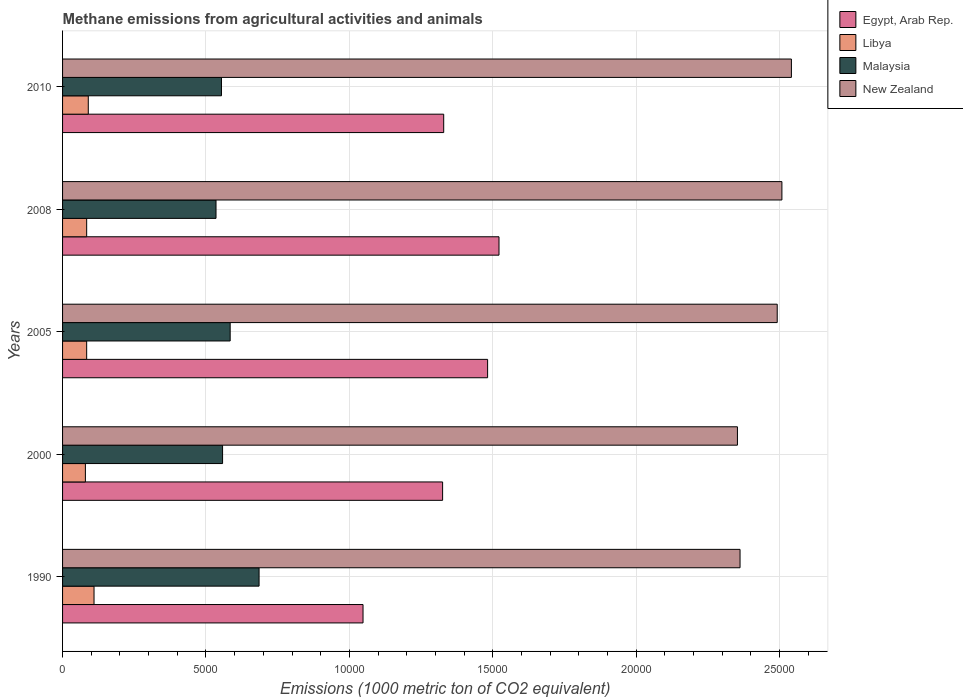How many different coloured bars are there?
Provide a succinct answer. 4. How many groups of bars are there?
Provide a succinct answer. 5. Are the number of bars on each tick of the Y-axis equal?
Make the answer very short. Yes. What is the label of the 4th group of bars from the top?
Make the answer very short. 2000. What is the amount of methane emitted in Egypt, Arab Rep. in 2005?
Offer a very short reply. 1.48e+04. Across all years, what is the maximum amount of methane emitted in Libya?
Offer a terse response. 1097.1. Across all years, what is the minimum amount of methane emitted in Libya?
Offer a terse response. 795.8. In which year was the amount of methane emitted in Malaysia minimum?
Your answer should be compact. 2008. What is the total amount of methane emitted in New Zealand in the graph?
Your response must be concise. 1.23e+05. What is the difference between the amount of methane emitted in New Zealand in 1990 and that in 2008?
Give a very brief answer. -1459.6. What is the difference between the amount of methane emitted in Egypt, Arab Rep. in 1990 and the amount of methane emitted in Libya in 2005?
Your response must be concise. 9635.4. What is the average amount of methane emitted in New Zealand per year?
Offer a very short reply. 2.45e+04. In the year 2005, what is the difference between the amount of methane emitted in Malaysia and amount of methane emitted in New Zealand?
Provide a short and direct response. -1.91e+04. What is the ratio of the amount of methane emitted in Malaysia in 2005 to that in 2010?
Offer a very short reply. 1.05. What is the difference between the highest and the second highest amount of methane emitted in Libya?
Your answer should be very brief. 200.3. What is the difference between the highest and the lowest amount of methane emitted in Malaysia?
Ensure brevity in your answer.  1501.2. In how many years, is the amount of methane emitted in Egypt, Arab Rep. greater than the average amount of methane emitted in Egypt, Arab Rep. taken over all years?
Your response must be concise. 2. Is it the case that in every year, the sum of the amount of methane emitted in Malaysia and amount of methane emitted in New Zealand is greater than the sum of amount of methane emitted in Libya and amount of methane emitted in Egypt, Arab Rep.?
Your answer should be compact. No. What does the 1st bar from the top in 2010 represents?
Your answer should be compact. New Zealand. What does the 3rd bar from the bottom in 2008 represents?
Ensure brevity in your answer.  Malaysia. Are the values on the major ticks of X-axis written in scientific E-notation?
Give a very brief answer. No. What is the title of the graph?
Provide a short and direct response. Methane emissions from agricultural activities and animals. What is the label or title of the X-axis?
Keep it short and to the point. Emissions (1000 metric ton of CO2 equivalent). What is the Emissions (1000 metric ton of CO2 equivalent) in Egypt, Arab Rep. in 1990?
Provide a short and direct response. 1.05e+04. What is the Emissions (1000 metric ton of CO2 equivalent) in Libya in 1990?
Provide a succinct answer. 1097.1. What is the Emissions (1000 metric ton of CO2 equivalent) of Malaysia in 1990?
Your answer should be compact. 6851.5. What is the Emissions (1000 metric ton of CO2 equivalent) of New Zealand in 1990?
Offer a very short reply. 2.36e+04. What is the Emissions (1000 metric ton of CO2 equivalent) of Egypt, Arab Rep. in 2000?
Ensure brevity in your answer.  1.33e+04. What is the Emissions (1000 metric ton of CO2 equivalent) in Libya in 2000?
Your response must be concise. 795.8. What is the Emissions (1000 metric ton of CO2 equivalent) of Malaysia in 2000?
Provide a short and direct response. 5579.2. What is the Emissions (1000 metric ton of CO2 equivalent) in New Zealand in 2000?
Make the answer very short. 2.35e+04. What is the Emissions (1000 metric ton of CO2 equivalent) of Egypt, Arab Rep. in 2005?
Provide a short and direct response. 1.48e+04. What is the Emissions (1000 metric ton of CO2 equivalent) of Libya in 2005?
Your answer should be very brief. 840.7. What is the Emissions (1000 metric ton of CO2 equivalent) in Malaysia in 2005?
Ensure brevity in your answer.  5844. What is the Emissions (1000 metric ton of CO2 equivalent) of New Zealand in 2005?
Ensure brevity in your answer.  2.49e+04. What is the Emissions (1000 metric ton of CO2 equivalent) of Egypt, Arab Rep. in 2008?
Give a very brief answer. 1.52e+04. What is the Emissions (1000 metric ton of CO2 equivalent) in Libya in 2008?
Ensure brevity in your answer.  840.7. What is the Emissions (1000 metric ton of CO2 equivalent) in Malaysia in 2008?
Provide a short and direct response. 5350.3. What is the Emissions (1000 metric ton of CO2 equivalent) in New Zealand in 2008?
Provide a succinct answer. 2.51e+04. What is the Emissions (1000 metric ton of CO2 equivalent) of Egypt, Arab Rep. in 2010?
Your answer should be very brief. 1.33e+04. What is the Emissions (1000 metric ton of CO2 equivalent) in Libya in 2010?
Make the answer very short. 896.8. What is the Emissions (1000 metric ton of CO2 equivalent) in Malaysia in 2010?
Your answer should be compact. 5540.3. What is the Emissions (1000 metric ton of CO2 equivalent) in New Zealand in 2010?
Keep it short and to the point. 2.54e+04. Across all years, what is the maximum Emissions (1000 metric ton of CO2 equivalent) in Egypt, Arab Rep.?
Ensure brevity in your answer.  1.52e+04. Across all years, what is the maximum Emissions (1000 metric ton of CO2 equivalent) of Libya?
Ensure brevity in your answer.  1097.1. Across all years, what is the maximum Emissions (1000 metric ton of CO2 equivalent) in Malaysia?
Keep it short and to the point. 6851.5. Across all years, what is the maximum Emissions (1000 metric ton of CO2 equivalent) of New Zealand?
Offer a very short reply. 2.54e+04. Across all years, what is the minimum Emissions (1000 metric ton of CO2 equivalent) of Egypt, Arab Rep.?
Make the answer very short. 1.05e+04. Across all years, what is the minimum Emissions (1000 metric ton of CO2 equivalent) in Libya?
Your answer should be very brief. 795.8. Across all years, what is the minimum Emissions (1000 metric ton of CO2 equivalent) in Malaysia?
Your answer should be compact. 5350.3. Across all years, what is the minimum Emissions (1000 metric ton of CO2 equivalent) in New Zealand?
Give a very brief answer. 2.35e+04. What is the total Emissions (1000 metric ton of CO2 equivalent) in Egypt, Arab Rep. in the graph?
Your response must be concise. 6.71e+04. What is the total Emissions (1000 metric ton of CO2 equivalent) in Libya in the graph?
Your response must be concise. 4471.1. What is the total Emissions (1000 metric ton of CO2 equivalent) of Malaysia in the graph?
Your response must be concise. 2.92e+04. What is the total Emissions (1000 metric ton of CO2 equivalent) in New Zealand in the graph?
Make the answer very short. 1.23e+05. What is the difference between the Emissions (1000 metric ton of CO2 equivalent) in Egypt, Arab Rep. in 1990 and that in 2000?
Keep it short and to the point. -2774.9. What is the difference between the Emissions (1000 metric ton of CO2 equivalent) in Libya in 1990 and that in 2000?
Provide a succinct answer. 301.3. What is the difference between the Emissions (1000 metric ton of CO2 equivalent) in Malaysia in 1990 and that in 2000?
Give a very brief answer. 1272.3. What is the difference between the Emissions (1000 metric ton of CO2 equivalent) in New Zealand in 1990 and that in 2000?
Provide a short and direct response. 90.9. What is the difference between the Emissions (1000 metric ton of CO2 equivalent) in Egypt, Arab Rep. in 1990 and that in 2005?
Ensure brevity in your answer.  -4343.8. What is the difference between the Emissions (1000 metric ton of CO2 equivalent) in Libya in 1990 and that in 2005?
Offer a very short reply. 256.4. What is the difference between the Emissions (1000 metric ton of CO2 equivalent) of Malaysia in 1990 and that in 2005?
Offer a very short reply. 1007.5. What is the difference between the Emissions (1000 metric ton of CO2 equivalent) in New Zealand in 1990 and that in 2005?
Provide a succinct answer. -1296. What is the difference between the Emissions (1000 metric ton of CO2 equivalent) in Egypt, Arab Rep. in 1990 and that in 2008?
Offer a terse response. -4741.1. What is the difference between the Emissions (1000 metric ton of CO2 equivalent) in Libya in 1990 and that in 2008?
Ensure brevity in your answer.  256.4. What is the difference between the Emissions (1000 metric ton of CO2 equivalent) of Malaysia in 1990 and that in 2008?
Give a very brief answer. 1501.2. What is the difference between the Emissions (1000 metric ton of CO2 equivalent) of New Zealand in 1990 and that in 2008?
Ensure brevity in your answer.  -1459.6. What is the difference between the Emissions (1000 metric ton of CO2 equivalent) in Egypt, Arab Rep. in 1990 and that in 2010?
Keep it short and to the point. -2813. What is the difference between the Emissions (1000 metric ton of CO2 equivalent) of Libya in 1990 and that in 2010?
Provide a succinct answer. 200.3. What is the difference between the Emissions (1000 metric ton of CO2 equivalent) of Malaysia in 1990 and that in 2010?
Provide a succinct answer. 1311.2. What is the difference between the Emissions (1000 metric ton of CO2 equivalent) of New Zealand in 1990 and that in 2010?
Offer a terse response. -1790.8. What is the difference between the Emissions (1000 metric ton of CO2 equivalent) of Egypt, Arab Rep. in 2000 and that in 2005?
Offer a terse response. -1568.9. What is the difference between the Emissions (1000 metric ton of CO2 equivalent) in Libya in 2000 and that in 2005?
Your response must be concise. -44.9. What is the difference between the Emissions (1000 metric ton of CO2 equivalent) in Malaysia in 2000 and that in 2005?
Offer a terse response. -264.8. What is the difference between the Emissions (1000 metric ton of CO2 equivalent) in New Zealand in 2000 and that in 2005?
Your answer should be very brief. -1386.9. What is the difference between the Emissions (1000 metric ton of CO2 equivalent) of Egypt, Arab Rep. in 2000 and that in 2008?
Your answer should be very brief. -1966.2. What is the difference between the Emissions (1000 metric ton of CO2 equivalent) in Libya in 2000 and that in 2008?
Your response must be concise. -44.9. What is the difference between the Emissions (1000 metric ton of CO2 equivalent) in Malaysia in 2000 and that in 2008?
Provide a succinct answer. 228.9. What is the difference between the Emissions (1000 metric ton of CO2 equivalent) in New Zealand in 2000 and that in 2008?
Your response must be concise. -1550.5. What is the difference between the Emissions (1000 metric ton of CO2 equivalent) in Egypt, Arab Rep. in 2000 and that in 2010?
Keep it short and to the point. -38.1. What is the difference between the Emissions (1000 metric ton of CO2 equivalent) of Libya in 2000 and that in 2010?
Offer a terse response. -101. What is the difference between the Emissions (1000 metric ton of CO2 equivalent) in Malaysia in 2000 and that in 2010?
Ensure brevity in your answer.  38.9. What is the difference between the Emissions (1000 metric ton of CO2 equivalent) of New Zealand in 2000 and that in 2010?
Keep it short and to the point. -1881.7. What is the difference between the Emissions (1000 metric ton of CO2 equivalent) of Egypt, Arab Rep. in 2005 and that in 2008?
Your answer should be compact. -397.3. What is the difference between the Emissions (1000 metric ton of CO2 equivalent) in Malaysia in 2005 and that in 2008?
Offer a very short reply. 493.7. What is the difference between the Emissions (1000 metric ton of CO2 equivalent) in New Zealand in 2005 and that in 2008?
Make the answer very short. -163.6. What is the difference between the Emissions (1000 metric ton of CO2 equivalent) of Egypt, Arab Rep. in 2005 and that in 2010?
Keep it short and to the point. 1530.8. What is the difference between the Emissions (1000 metric ton of CO2 equivalent) of Libya in 2005 and that in 2010?
Your response must be concise. -56.1. What is the difference between the Emissions (1000 metric ton of CO2 equivalent) in Malaysia in 2005 and that in 2010?
Provide a short and direct response. 303.7. What is the difference between the Emissions (1000 metric ton of CO2 equivalent) in New Zealand in 2005 and that in 2010?
Give a very brief answer. -494.8. What is the difference between the Emissions (1000 metric ton of CO2 equivalent) of Egypt, Arab Rep. in 2008 and that in 2010?
Your answer should be very brief. 1928.1. What is the difference between the Emissions (1000 metric ton of CO2 equivalent) of Libya in 2008 and that in 2010?
Your answer should be compact. -56.1. What is the difference between the Emissions (1000 metric ton of CO2 equivalent) in Malaysia in 2008 and that in 2010?
Offer a very short reply. -190. What is the difference between the Emissions (1000 metric ton of CO2 equivalent) in New Zealand in 2008 and that in 2010?
Make the answer very short. -331.2. What is the difference between the Emissions (1000 metric ton of CO2 equivalent) in Egypt, Arab Rep. in 1990 and the Emissions (1000 metric ton of CO2 equivalent) in Libya in 2000?
Your response must be concise. 9680.3. What is the difference between the Emissions (1000 metric ton of CO2 equivalent) in Egypt, Arab Rep. in 1990 and the Emissions (1000 metric ton of CO2 equivalent) in Malaysia in 2000?
Your answer should be compact. 4896.9. What is the difference between the Emissions (1000 metric ton of CO2 equivalent) in Egypt, Arab Rep. in 1990 and the Emissions (1000 metric ton of CO2 equivalent) in New Zealand in 2000?
Offer a terse response. -1.31e+04. What is the difference between the Emissions (1000 metric ton of CO2 equivalent) of Libya in 1990 and the Emissions (1000 metric ton of CO2 equivalent) of Malaysia in 2000?
Provide a succinct answer. -4482.1. What is the difference between the Emissions (1000 metric ton of CO2 equivalent) in Libya in 1990 and the Emissions (1000 metric ton of CO2 equivalent) in New Zealand in 2000?
Your answer should be compact. -2.24e+04. What is the difference between the Emissions (1000 metric ton of CO2 equivalent) in Malaysia in 1990 and the Emissions (1000 metric ton of CO2 equivalent) in New Zealand in 2000?
Ensure brevity in your answer.  -1.67e+04. What is the difference between the Emissions (1000 metric ton of CO2 equivalent) of Egypt, Arab Rep. in 1990 and the Emissions (1000 metric ton of CO2 equivalent) of Libya in 2005?
Provide a short and direct response. 9635.4. What is the difference between the Emissions (1000 metric ton of CO2 equivalent) of Egypt, Arab Rep. in 1990 and the Emissions (1000 metric ton of CO2 equivalent) of Malaysia in 2005?
Ensure brevity in your answer.  4632.1. What is the difference between the Emissions (1000 metric ton of CO2 equivalent) in Egypt, Arab Rep. in 1990 and the Emissions (1000 metric ton of CO2 equivalent) in New Zealand in 2005?
Offer a terse response. -1.44e+04. What is the difference between the Emissions (1000 metric ton of CO2 equivalent) in Libya in 1990 and the Emissions (1000 metric ton of CO2 equivalent) in Malaysia in 2005?
Provide a short and direct response. -4746.9. What is the difference between the Emissions (1000 metric ton of CO2 equivalent) in Libya in 1990 and the Emissions (1000 metric ton of CO2 equivalent) in New Zealand in 2005?
Keep it short and to the point. -2.38e+04. What is the difference between the Emissions (1000 metric ton of CO2 equivalent) of Malaysia in 1990 and the Emissions (1000 metric ton of CO2 equivalent) of New Zealand in 2005?
Ensure brevity in your answer.  -1.81e+04. What is the difference between the Emissions (1000 metric ton of CO2 equivalent) of Egypt, Arab Rep. in 1990 and the Emissions (1000 metric ton of CO2 equivalent) of Libya in 2008?
Your answer should be very brief. 9635.4. What is the difference between the Emissions (1000 metric ton of CO2 equivalent) in Egypt, Arab Rep. in 1990 and the Emissions (1000 metric ton of CO2 equivalent) in Malaysia in 2008?
Your response must be concise. 5125.8. What is the difference between the Emissions (1000 metric ton of CO2 equivalent) in Egypt, Arab Rep. in 1990 and the Emissions (1000 metric ton of CO2 equivalent) in New Zealand in 2008?
Make the answer very short. -1.46e+04. What is the difference between the Emissions (1000 metric ton of CO2 equivalent) of Libya in 1990 and the Emissions (1000 metric ton of CO2 equivalent) of Malaysia in 2008?
Your answer should be compact. -4253.2. What is the difference between the Emissions (1000 metric ton of CO2 equivalent) in Libya in 1990 and the Emissions (1000 metric ton of CO2 equivalent) in New Zealand in 2008?
Make the answer very short. -2.40e+04. What is the difference between the Emissions (1000 metric ton of CO2 equivalent) in Malaysia in 1990 and the Emissions (1000 metric ton of CO2 equivalent) in New Zealand in 2008?
Make the answer very short. -1.82e+04. What is the difference between the Emissions (1000 metric ton of CO2 equivalent) in Egypt, Arab Rep. in 1990 and the Emissions (1000 metric ton of CO2 equivalent) in Libya in 2010?
Give a very brief answer. 9579.3. What is the difference between the Emissions (1000 metric ton of CO2 equivalent) in Egypt, Arab Rep. in 1990 and the Emissions (1000 metric ton of CO2 equivalent) in Malaysia in 2010?
Keep it short and to the point. 4935.8. What is the difference between the Emissions (1000 metric ton of CO2 equivalent) of Egypt, Arab Rep. in 1990 and the Emissions (1000 metric ton of CO2 equivalent) of New Zealand in 2010?
Give a very brief answer. -1.49e+04. What is the difference between the Emissions (1000 metric ton of CO2 equivalent) of Libya in 1990 and the Emissions (1000 metric ton of CO2 equivalent) of Malaysia in 2010?
Offer a terse response. -4443.2. What is the difference between the Emissions (1000 metric ton of CO2 equivalent) in Libya in 1990 and the Emissions (1000 metric ton of CO2 equivalent) in New Zealand in 2010?
Your response must be concise. -2.43e+04. What is the difference between the Emissions (1000 metric ton of CO2 equivalent) in Malaysia in 1990 and the Emissions (1000 metric ton of CO2 equivalent) in New Zealand in 2010?
Provide a succinct answer. -1.86e+04. What is the difference between the Emissions (1000 metric ton of CO2 equivalent) of Egypt, Arab Rep. in 2000 and the Emissions (1000 metric ton of CO2 equivalent) of Libya in 2005?
Your answer should be compact. 1.24e+04. What is the difference between the Emissions (1000 metric ton of CO2 equivalent) of Egypt, Arab Rep. in 2000 and the Emissions (1000 metric ton of CO2 equivalent) of Malaysia in 2005?
Your answer should be compact. 7407. What is the difference between the Emissions (1000 metric ton of CO2 equivalent) of Egypt, Arab Rep. in 2000 and the Emissions (1000 metric ton of CO2 equivalent) of New Zealand in 2005?
Give a very brief answer. -1.17e+04. What is the difference between the Emissions (1000 metric ton of CO2 equivalent) of Libya in 2000 and the Emissions (1000 metric ton of CO2 equivalent) of Malaysia in 2005?
Provide a short and direct response. -5048.2. What is the difference between the Emissions (1000 metric ton of CO2 equivalent) in Libya in 2000 and the Emissions (1000 metric ton of CO2 equivalent) in New Zealand in 2005?
Offer a very short reply. -2.41e+04. What is the difference between the Emissions (1000 metric ton of CO2 equivalent) of Malaysia in 2000 and the Emissions (1000 metric ton of CO2 equivalent) of New Zealand in 2005?
Your answer should be compact. -1.93e+04. What is the difference between the Emissions (1000 metric ton of CO2 equivalent) in Egypt, Arab Rep. in 2000 and the Emissions (1000 metric ton of CO2 equivalent) in Libya in 2008?
Provide a short and direct response. 1.24e+04. What is the difference between the Emissions (1000 metric ton of CO2 equivalent) of Egypt, Arab Rep. in 2000 and the Emissions (1000 metric ton of CO2 equivalent) of Malaysia in 2008?
Keep it short and to the point. 7900.7. What is the difference between the Emissions (1000 metric ton of CO2 equivalent) of Egypt, Arab Rep. in 2000 and the Emissions (1000 metric ton of CO2 equivalent) of New Zealand in 2008?
Give a very brief answer. -1.18e+04. What is the difference between the Emissions (1000 metric ton of CO2 equivalent) of Libya in 2000 and the Emissions (1000 metric ton of CO2 equivalent) of Malaysia in 2008?
Your response must be concise. -4554.5. What is the difference between the Emissions (1000 metric ton of CO2 equivalent) in Libya in 2000 and the Emissions (1000 metric ton of CO2 equivalent) in New Zealand in 2008?
Keep it short and to the point. -2.43e+04. What is the difference between the Emissions (1000 metric ton of CO2 equivalent) in Malaysia in 2000 and the Emissions (1000 metric ton of CO2 equivalent) in New Zealand in 2008?
Your response must be concise. -1.95e+04. What is the difference between the Emissions (1000 metric ton of CO2 equivalent) in Egypt, Arab Rep. in 2000 and the Emissions (1000 metric ton of CO2 equivalent) in Libya in 2010?
Offer a very short reply. 1.24e+04. What is the difference between the Emissions (1000 metric ton of CO2 equivalent) of Egypt, Arab Rep. in 2000 and the Emissions (1000 metric ton of CO2 equivalent) of Malaysia in 2010?
Your answer should be very brief. 7710.7. What is the difference between the Emissions (1000 metric ton of CO2 equivalent) of Egypt, Arab Rep. in 2000 and the Emissions (1000 metric ton of CO2 equivalent) of New Zealand in 2010?
Your answer should be very brief. -1.22e+04. What is the difference between the Emissions (1000 metric ton of CO2 equivalent) of Libya in 2000 and the Emissions (1000 metric ton of CO2 equivalent) of Malaysia in 2010?
Give a very brief answer. -4744.5. What is the difference between the Emissions (1000 metric ton of CO2 equivalent) of Libya in 2000 and the Emissions (1000 metric ton of CO2 equivalent) of New Zealand in 2010?
Offer a very short reply. -2.46e+04. What is the difference between the Emissions (1000 metric ton of CO2 equivalent) of Malaysia in 2000 and the Emissions (1000 metric ton of CO2 equivalent) of New Zealand in 2010?
Your response must be concise. -1.98e+04. What is the difference between the Emissions (1000 metric ton of CO2 equivalent) of Egypt, Arab Rep. in 2005 and the Emissions (1000 metric ton of CO2 equivalent) of Libya in 2008?
Your answer should be very brief. 1.40e+04. What is the difference between the Emissions (1000 metric ton of CO2 equivalent) of Egypt, Arab Rep. in 2005 and the Emissions (1000 metric ton of CO2 equivalent) of Malaysia in 2008?
Give a very brief answer. 9469.6. What is the difference between the Emissions (1000 metric ton of CO2 equivalent) in Egypt, Arab Rep. in 2005 and the Emissions (1000 metric ton of CO2 equivalent) in New Zealand in 2008?
Offer a very short reply. -1.03e+04. What is the difference between the Emissions (1000 metric ton of CO2 equivalent) of Libya in 2005 and the Emissions (1000 metric ton of CO2 equivalent) of Malaysia in 2008?
Your answer should be compact. -4509.6. What is the difference between the Emissions (1000 metric ton of CO2 equivalent) in Libya in 2005 and the Emissions (1000 metric ton of CO2 equivalent) in New Zealand in 2008?
Ensure brevity in your answer.  -2.42e+04. What is the difference between the Emissions (1000 metric ton of CO2 equivalent) in Malaysia in 2005 and the Emissions (1000 metric ton of CO2 equivalent) in New Zealand in 2008?
Make the answer very short. -1.92e+04. What is the difference between the Emissions (1000 metric ton of CO2 equivalent) of Egypt, Arab Rep. in 2005 and the Emissions (1000 metric ton of CO2 equivalent) of Libya in 2010?
Your response must be concise. 1.39e+04. What is the difference between the Emissions (1000 metric ton of CO2 equivalent) in Egypt, Arab Rep. in 2005 and the Emissions (1000 metric ton of CO2 equivalent) in Malaysia in 2010?
Make the answer very short. 9279.6. What is the difference between the Emissions (1000 metric ton of CO2 equivalent) in Egypt, Arab Rep. in 2005 and the Emissions (1000 metric ton of CO2 equivalent) in New Zealand in 2010?
Your response must be concise. -1.06e+04. What is the difference between the Emissions (1000 metric ton of CO2 equivalent) of Libya in 2005 and the Emissions (1000 metric ton of CO2 equivalent) of Malaysia in 2010?
Offer a very short reply. -4699.6. What is the difference between the Emissions (1000 metric ton of CO2 equivalent) of Libya in 2005 and the Emissions (1000 metric ton of CO2 equivalent) of New Zealand in 2010?
Your response must be concise. -2.46e+04. What is the difference between the Emissions (1000 metric ton of CO2 equivalent) of Malaysia in 2005 and the Emissions (1000 metric ton of CO2 equivalent) of New Zealand in 2010?
Offer a very short reply. -1.96e+04. What is the difference between the Emissions (1000 metric ton of CO2 equivalent) of Egypt, Arab Rep. in 2008 and the Emissions (1000 metric ton of CO2 equivalent) of Libya in 2010?
Keep it short and to the point. 1.43e+04. What is the difference between the Emissions (1000 metric ton of CO2 equivalent) in Egypt, Arab Rep. in 2008 and the Emissions (1000 metric ton of CO2 equivalent) in Malaysia in 2010?
Offer a very short reply. 9676.9. What is the difference between the Emissions (1000 metric ton of CO2 equivalent) in Egypt, Arab Rep. in 2008 and the Emissions (1000 metric ton of CO2 equivalent) in New Zealand in 2010?
Offer a very short reply. -1.02e+04. What is the difference between the Emissions (1000 metric ton of CO2 equivalent) of Libya in 2008 and the Emissions (1000 metric ton of CO2 equivalent) of Malaysia in 2010?
Offer a very short reply. -4699.6. What is the difference between the Emissions (1000 metric ton of CO2 equivalent) in Libya in 2008 and the Emissions (1000 metric ton of CO2 equivalent) in New Zealand in 2010?
Offer a very short reply. -2.46e+04. What is the difference between the Emissions (1000 metric ton of CO2 equivalent) in Malaysia in 2008 and the Emissions (1000 metric ton of CO2 equivalent) in New Zealand in 2010?
Your answer should be very brief. -2.01e+04. What is the average Emissions (1000 metric ton of CO2 equivalent) in Egypt, Arab Rep. per year?
Provide a short and direct response. 1.34e+04. What is the average Emissions (1000 metric ton of CO2 equivalent) in Libya per year?
Ensure brevity in your answer.  894.22. What is the average Emissions (1000 metric ton of CO2 equivalent) of Malaysia per year?
Make the answer very short. 5833.06. What is the average Emissions (1000 metric ton of CO2 equivalent) of New Zealand per year?
Your response must be concise. 2.45e+04. In the year 1990, what is the difference between the Emissions (1000 metric ton of CO2 equivalent) of Egypt, Arab Rep. and Emissions (1000 metric ton of CO2 equivalent) of Libya?
Provide a succinct answer. 9379. In the year 1990, what is the difference between the Emissions (1000 metric ton of CO2 equivalent) in Egypt, Arab Rep. and Emissions (1000 metric ton of CO2 equivalent) in Malaysia?
Offer a very short reply. 3624.6. In the year 1990, what is the difference between the Emissions (1000 metric ton of CO2 equivalent) in Egypt, Arab Rep. and Emissions (1000 metric ton of CO2 equivalent) in New Zealand?
Your response must be concise. -1.31e+04. In the year 1990, what is the difference between the Emissions (1000 metric ton of CO2 equivalent) of Libya and Emissions (1000 metric ton of CO2 equivalent) of Malaysia?
Your response must be concise. -5754.4. In the year 1990, what is the difference between the Emissions (1000 metric ton of CO2 equivalent) in Libya and Emissions (1000 metric ton of CO2 equivalent) in New Zealand?
Your answer should be compact. -2.25e+04. In the year 1990, what is the difference between the Emissions (1000 metric ton of CO2 equivalent) in Malaysia and Emissions (1000 metric ton of CO2 equivalent) in New Zealand?
Your response must be concise. -1.68e+04. In the year 2000, what is the difference between the Emissions (1000 metric ton of CO2 equivalent) of Egypt, Arab Rep. and Emissions (1000 metric ton of CO2 equivalent) of Libya?
Make the answer very short. 1.25e+04. In the year 2000, what is the difference between the Emissions (1000 metric ton of CO2 equivalent) in Egypt, Arab Rep. and Emissions (1000 metric ton of CO2 equivalent) in Malaysia?
Offer a terse response. 7671.8. In the year 2000, what is the difference between the Emissions (1000 metric ton of CO2 equivalent) in Egypt, Arab Rep. and Emissions (1000 metric ton of CO2 equivalent) in New Zealand?
Offer a terse response. -1.03e+04. In the year 2000, what is the difference between the Emissions (1000 metric ton of CO2 equivalent) of Libya and Emissions (1000 metric ton of CO2 equivalent) of Malaysia?
Make the answer very short. -4783.4. In the year 2000, what is the difference between the Emissions (1000 metric ton of CO2 equivalent) of Libya and Emissions (1000 metric ton of CO2 equivalent) of New Zealand?
Keep it short and to the point. -2.27e+04. In the year 2000, what is the difference between the Emissions (1000 metric ton of CO2 equivalent) in Malaysia and Emissions (1000 metric ton of CO2 equivalent) in New Zealand?
Offer a terse response. -1.80e+04. In the year 2005, what is the difference between the Emissions (1000 metric ton of CO2 equivalent) of Egypt, Arab Rep. and Emissions (1000 metric ton of CO2 equivalent) of Libya?
Ensure brevity in your answer.  1.40e+04. In the year 2005, what is the difference between the Emissions (1000 metric ton of CO2 equivalent) of Egypt, Arab Rep. and Emissions (1000 metric ton of CO2 equivalent) of Malaysia?
Offer a terse response. 8975.9. In the year 2005, what is the difference between the Emissions (1000 metric ton of CO2 equivalent) in Egypt, Arab Rep. and Emissions (1000 metric ton of CO2 equivalent) in New Zealand?
Provide a succinct answer. -1.01e+04. In the year 2005, what is the difference between the Emissions (1000 metric ton of CO2 equivalent) in Libya and Emissions (1000 metric ton of CO2 equivalent) in Malaysia?
Your response must be concise. -5003.3. In the year 2005, what is the difference between the Emissions (1000 metric ton of CO2 equivalent) of Libya and Emissions (1000 metric ton of CO2 equivalent) of New Zealand?
Make the answer very short. -2.41e+04. In the year 2005, what is the difference between the Emissions (1000 metric ton of CO2 equivalent) in Malaysia and Emissions (1000 metric ton of CO2 equivalent) in New Zealand?
Your response must be concise. -1.91e+04. In the year 2008, what is the difference between the Emissions (1000 metric ton of CO2 equivalent) in Egypt, Arab Rep. and Emissions (1000 metric ton of CO2 equivalent) in Libya?
Offer a very short reply. 1.44e+04. In the year 2008, what is the difference between the Emissions (1000 metric ton of CO2 equivalent) in Egypt, Arab Rep. and Emissions (1000 metric ton of CO2 equivalent) in Malaysia?
Give a very brief answer. 9866.9. In the year 2008, what is the difference between the Emissions (1000 metric ton of CO2 equivalent) of Egypt, Arab Rep. and Emissions (1000 metric ton of CO2 equivalent) of New Zealand?
Keep it short and to the point. -9864. In the year 2008, what is the difference between the Emissions (1000 metric ton of CO2 equivalent) of Libya and Emissions (1000 metric ton of CO2 equivalent) of Malaysia?
Your answer should be compact. -4509.6. In the year 2008, what is the difference between the Emissions (1000 metric ton of CO2 equivalent) of Libya and Emissions (1000 metric ton of CO2 equivalent) of New Zealand?
Your response must be concise. -2.42e+04. In the year 2008, what is the difference between the Emissions (1000 metric ton of CO2 equivalent) in Malaysia and Emissions (1000 metric ton of CO2 equivalent) in New Zealand?
Offer a terse response. -1.97e+04. In the year 2010, what is the difference between the Emissions (1000 metric ton of CO2 equivalent) in Egypt, Arab Rep. and Emissions (1000 metric ton of CO2 equivalent) in Libya?
Your response must be concise. 1.24e+04. In the year 2010, what is the difference between the Emissions (1000 metric ton of CO2 equivalent) in Egypt, Arab Rep. and Emissions (1000 metric ton of CO2 equivalent) in Malaysia?
Give a very brief answer. 7748.8. In the year 2010, what is the difference between the Emissions (1000 metric ton of CO2 equivalent) of Egypt, Arab Rep. and Emissions (1000 metric ton of CO2 equivalent) of New Zealand?
Offer a terse response. -1.21e+04. In the year 2010, what is the difference between the Emissions (1000 metric ton of CO2 equivalent) of Libya and Emissions (1000 metric ton of CO2 equivalent) of Malaysia?
Your response must be concise. -4643.5. In the year 2010, what is the difference between the Emissions (1000 metric ton of CO2 equivalent) of Libya and Emissions (1000 metric ton of CO2 equivalent) of New Zealand?
Keep it short and to the point. -2.45e+04. In the year 2010, what is the difference between the Emissions (1000 metric ton of CO2 equivalent) in Malaysia and Emissions (1000 metric ton of CO2 equivalent) in New Zealand?
Make the answer very short. -1.99e+04. What is the ratio of the Emissions (1000 metric ton of CO2 equivalent) in Egypt, Arab Rep. in 1990 to that in 2000?
Your answer should be compact. 0.79. What is the ratio of the Emissions (1000 metric ton of CO2 equivalent) of Libya in 1990 to that in 2000?
Give a very brief answer. 1.38. What is the ratio of the Emissions (1000 metric ton of CO2 equivalent) of Malaysia in 1990 to that in 2000?
Offer a very short reply. 1.23. What is the ratio of the Emissions (1000 metric ton of CO2 equivalent) in Egypt, Arab Rep. in 1990 to that in 2005?
Make the answer very short. 0.71. What is the ratio of the Emissions (1000 metric ton of CO2 equivalent) of Libya in 1990 to that in 2005?
Provide a short and direct response. 1.3. What is the ratio of the Emissions (1000 metric ton of CO2 equivalent) of Malaysia in 1990 to that in 2005?
Provide a succinct answer. 1.17. What is the ratio of the Emissions (1000 metric ton of CO2 equivalent) of New Zealand in 1990 to that in 2005?
Your answer should be compact. 0.95. What is the ratio of the Emissions (1000 metric ton of CO2 equivalent) in Egypt, Arab Rep. in 1990 to that in 2008?
Offer a very short reply. 0.69. What is the ratio of the Emissions (1000 metric ton of CO2 equivalent) of Libya in 1990 to that in 2008?
Offer a terse response. 1.3. What is the ratio of the Emissions (1000 metric ton of CO2 equivalent) in Malaysia in 1990 to that in 2008?
Keep it short and to the point. 1.28. What is the ratio of the Emissions (1000 metric ton of CO2 equivalent) in New Zealand in 1990 to that in 2008?
Provide a short and direct response. 0.94. What is the ratio of the Emissions (1000 metric ton of CO2 equivalent) in Egypt, Arab Rep. in 1990 to that in 2010?
Provide a short and direct response. 0.79. What is the ratio of the Emissions (1000 metric ton of CO2 equivalent) in Libya in 1990 to that in 2010?
Offer a very short reply. 1.22. What is the ratio of the Emissions (1000 metric ton of CO2 equivalent) in Malaysia in 1990 to that in 2010?
Offer a terse response. 1.24. What is the ratio of the Emissions (1000 metric ton of CO2 equivalent) of New Zealand in 1990 to that in 2010?
Your answer should be compact. 0.93. What is the ratio of the Emissions (1000 metric ton of CO2 equivalent) of Egypt, Arab Rep. in 2000 to that in 2005?
Provide a succinct answer. 0.89. What is the ratio of the Emissions (1000 metric ton of CO2 equivalent) of Libya in 2000 to that in 2005?
Give a very brief answer. 0.95. What is the ratio of the Emissions (1000 metric ton of CO2 equivalent) of Malaysia in 2000 to that in 2005?
Your response must be concise. 0.95. What is the ratio of the Emissions (1000 metric ton of CO2 equivalent) in New Zealand in 2000 to that in 2005?
Ensure brevity in your answer.  0.94. What is the ratio of the Emissions (1000 metric ton of CO2 equivalent) in Egypt, Arab Rep. in 2000 to that in 2008?
Ensure brevity in your answer.  0.87. What is the ratio of the Emissions (1000 metric ton of CO2 equivalent) of Libya in 2000 to that in 2008?
Your response must be concise. 0.95. What is the ratio of the Emissions (1000 metric ton of CO2 equivalent) in Malaysia in 2000 to that in 2008?
Provide a succinct answer. 1.04. What is the ratio of the Emissions (1000 metric ton of CO2 equivalent) in New Zealand in 2000 to that in 2008?
Your answer should be very brief. 0.94. What is the ratio of the Emissions (1000 metric ton of CO2 equivalent) of Libya in 2000 to that in 2010?
Provide a short and direct response. 0.89. What is the ratio of the Emissions (1000 metric ton of CO2 equivalent) in New Zealand in 2000 to that in 2010?
Your response must be concise. 0.93. What is the ratio of the Emissions (1000 metric ton of CO2 equivalent) of Egypt, Arab Rep. in 2005 to that in 2008?
Give a very brief answer. 0.97. What is the ratio of the Emissions (1000 metric ton of CO2 equivalent) of Libya in 2005 to that in 2008?
Make the answer very short. 1. What is the ratio of the Emissions (1000 metric ton of CO2 equivalent) of Malaysia in 2005 to that in 2008?
Keep it short and to the point. 1.09. What is the ratio of the Emissions (1000 metric ton of CO2 equivalent) in New Zealand in 2005 to that in 2008?
Your answer should be compact. 0.99. What is the ratio of the Emissions (1000 metric ton of CO2 equivalent) in Egypt, Arab Rep. in 2005 to that in 2010?
Ensure brevity in your answer.  1.12. What is the ratio of the Emissions (1000 metric ton of CO2 equivalent) of Libya in 2005 to that in 2010?
Your answer should be very brief. 0.94. What is the ratio of the Emissions (1000 metric ton of CO2 equivalent) in Malaysia in 2005 to that in 2010?
Offer a very short reply. 1.05. What is the ratio of the Emissions (1000 metric ton of CO2 equivalent) of New Zealand in 2005 to that in 2010?
Provide a succinct answer. 0.98. What is the ratio of the Emissions (1000 metric ton of CO2 equivalent) in Egypt, Arab Rep. in 2008 to that in 2010?
Make the answer very short. 1.15. What is the ratio of the Emissions (1000 metric ton of CO2 equivalent) of Libya in 2008 to that in 2010?
Provide a short and direct response. 0.94. What is the ratio of the Emissions (1000 metric ton of CO2 equivalent) of Malaysia in 2008 to that in 2010?
Keep it short and to the point. 0.97. What is the ratio of the Emissions (1000 metric ton of CO2 equivalent) of New Zealand in 2008 to that in 2010?
Give a very brief answer. 0.99. What is the difference between the highest and the second highest Emissions (1000 metric ton of CO2 equivalent) in Egypt, Arab Rep.?
Offer a very short reply. 397.3. What is the difference between the highest and the second highest Emissions (1000 metric ton of CO2 equivalent) of Libya?
Your answer should be compact. 200.3. What is the difference between the highest and the second highest Emissions (1000 metric ton of CO2 equivalent) in Malaysia?
Make the answer very short. 1007.5. What is the difference between the highest and the second highest Emissions (1000 metric ton of CO2 equivalent) of New Zealand?
Provide a short and direct response. 331.2. What is the difference between the highest and the lowest Emissions (1000 metric ton of CO2 equivalent) in Egypt, Arab Rep.?
Ensure brevity in your answer.  4741.1. What is the difference between the highest and the lowest Emissions (1000 metric ton of CO2 equivalent) in Libya?
Keep it short and to the point. 301.3. What is the difference between the highest and the lowest Emissions (1000 metric ton of CO2 equivalent) in Malaysia?
Make the answer very short. 1501.2. What is the difference between the highest and the lowest Emissions (1000 metric ton of CO2 equivalent) in New Zealand?
Offer a very short reply. 1881.7. 